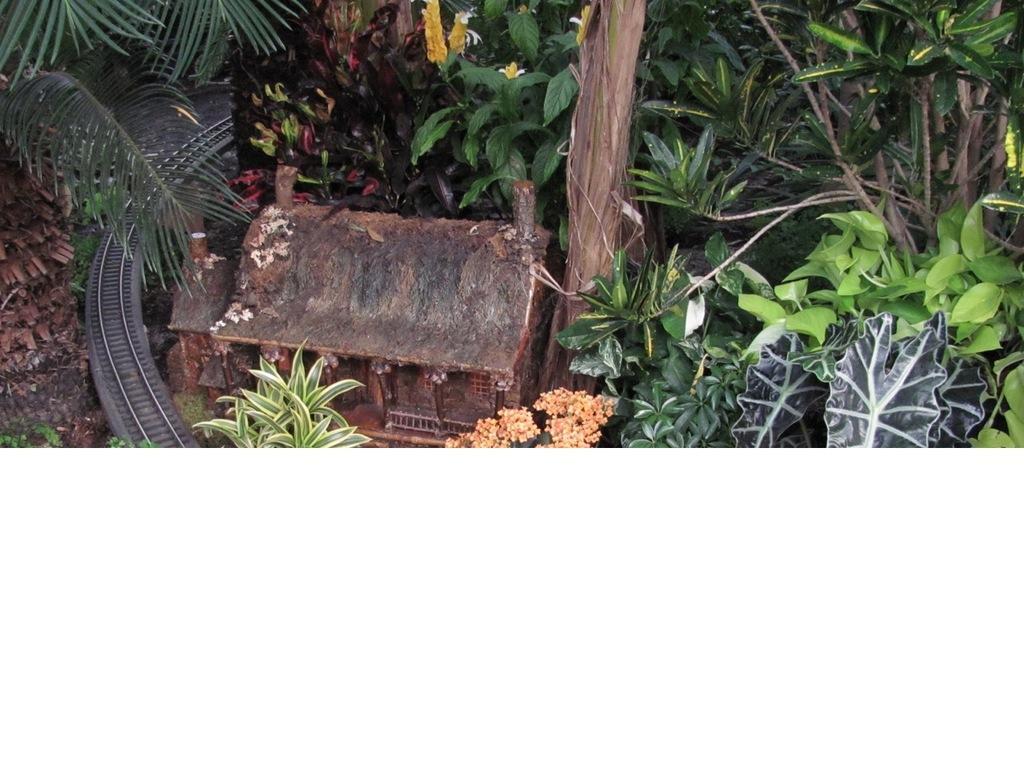Can you describe this image briefly? In this image I see the planets and I see the miniature of a house and the track. 